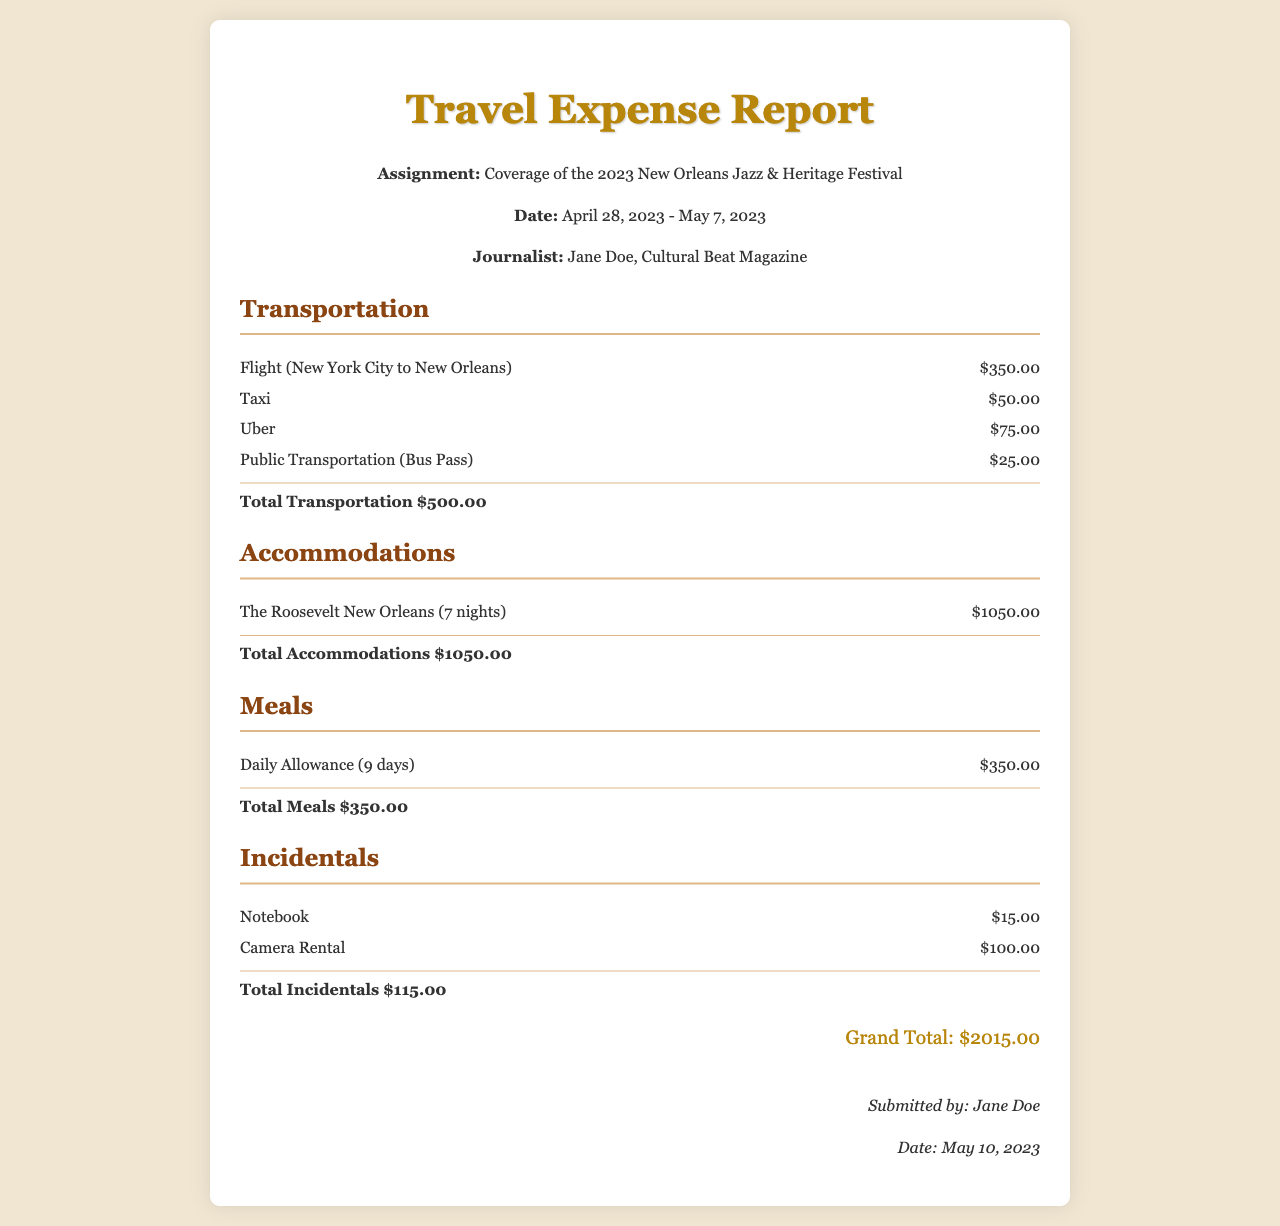What is the assignment? The assignment is specified in the header as covering the 2023 New Orleans Jazz & Heritage Festival.
Answer: Coverage of the 2023 New Orleans Jazz & Heritage Festival What are the dates of the assignment? The dates are stated clearly in the header, from April 28, 2023, to May 7, 2023.
Answer: April 28, 2023 - May 7, 2023 How much was spent on Flight from New York City to New Orleans? The expense for the flight is listed under transportation, amounting to $350.00.
Answer: $350.00 What is the total cost for accommodations? The total cost for accommodations is provided in the accommodations section as $1050.00.
Answer: $1050.00 How much did the journalist spend on meals? The total amount spent on meals is indicated as $350.00 in the meals section.
Answer: $350.00 What is the grand total of all expenses? The grand total is calculated and provided at the bottom of the document as $2015.00.
Answer: $2015.00 What incidentals were reported? The incidentals reported include a notebook and a camera rental.
Answer: Notebook, Camera Rental Who submitted the travel expense report? The report is submitted by the journalist named Jane Doe.
Answer: Jane Doe When was the travel expense report submitted? The submission date is noted at the end of the report as May 10, 2023.
Answer: May 10, 2023 